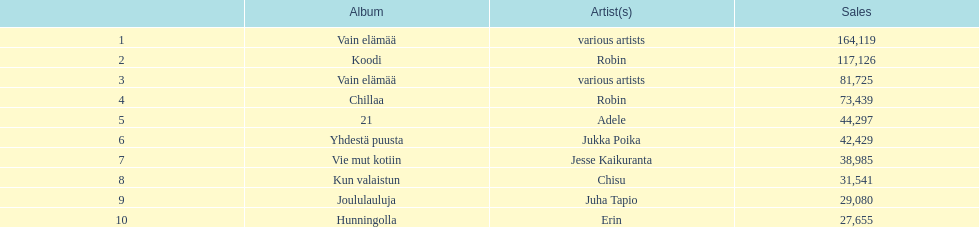Does adele or chisu have the highest number of sales? Adele. 